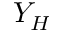<formula> <loc_0><loc_0><loc_500><loc_500>Y _ { H }</formula> 